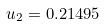<formula> <loc_0><loc_0><loc_500><loc_500>u _ { 2 } = 0 . 2 1 4 9 5</formula> 